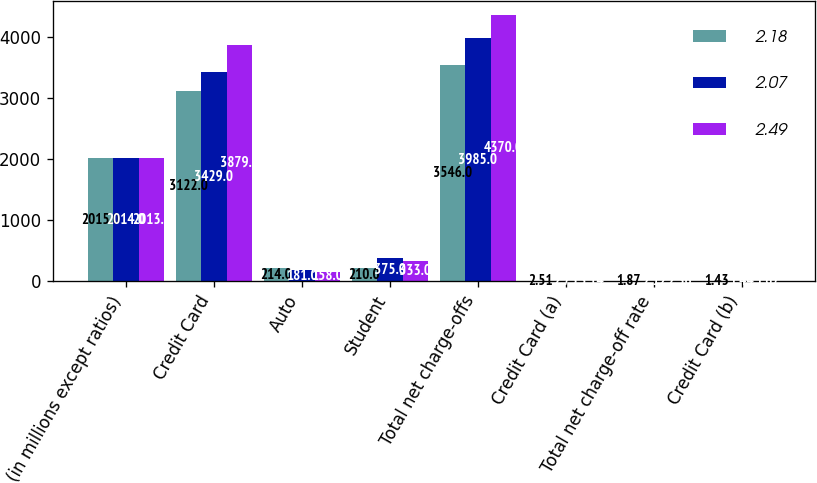Convert chart to OTSL. <chart><loc_0><loc_0><loc_500><loc_500><stacked_bar_chart><ecel><fcel>(in millions except ratios)<fcel>Credit Card<fcel>Auto<fcel>Student<fcel>Total net charge-offs<fcel>Credit Card (a)<fcel>Total net charge-off rate<fcel>Credit Card (b)<nl><fcel>2.18<fcel>2015<fcel>3122<fcel>214<fcel>210<fcel>3546<fcel>2.51<fcel>1.87<fcel>1.43<nl><fcel>2.07<fcel>2014<fcel>3429<fcel>181<fcel>375<fcel>3985<fcel>2.75<fcel>2.12<fcel>1.44<nl><fcel>2.49<fcel>2013<fcel>3879<fcel>158<fcel>333<fcel>4370<fcel>3.14<fcel>2.36<fcel>1.67<nl></chart> 